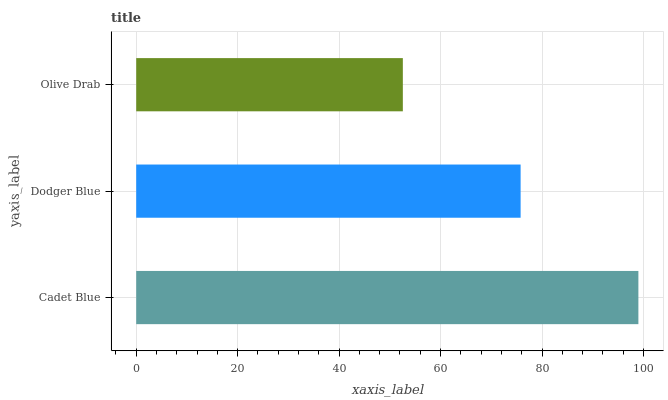Is Olive Drab the minimum?
Answer yes or no. Yes. Is Cadet Blue the maximum?
Answer yes or no. Yes. Is Dodger Blue the minimum?
Answer yes or no. No. Is Dodger Blue the maximum?
Answer yes or no. No. Is Cadet Blue greater than Dodger Blue?
Answer yes or no. Yes. Is Dodger Blue less than Cadet Blue?
Answer yes or no. Yes. Is Dodger Blue greater than Cadet Blue?
Answer yes or no. No. Is Cadet Blue less than Dodger Blue?
Answer yes or no. No. Is Dodger Blue the high median?
Answer yes or no. Yes. Is Dodger Blue the low median?
Answer yes or no. Yes. Is Olive Drab the high median?
Answer yes or no. No. Is Olive Drab the low median?
Answer yes or no. No. 